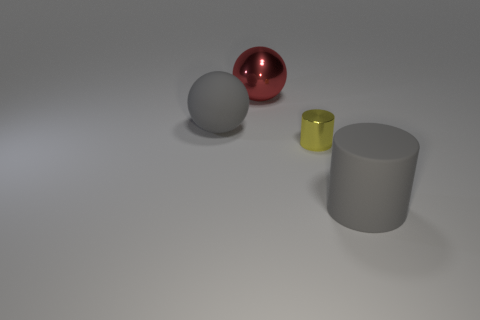There is a big gray matte thing that is in front of the small shiny cylinder; is its shape the same as the shiny object on the right side of the red metallic sphere?
Your answer should be very brief. Yes. How many rubber things are the same color as the matte cylinder?
Your response must be concise. 1. Is there a red rubber object of the same size as the matte cylinder?
Ensure brevity in your answer.  No. There is a rubber object left of the metal cylinder; does it have the same shape as the yellow object?
Ensure brevity in your answer.  No. Does the small yellow object have the same shape as the red thing?
Provide a succinct answer. No. Is there a big red object of the same shape as the small yellow object?
Offer a very short reply. No. There is a big gray matte thing to the left of the rubber thing that is in front of the tiny shiny thing; what shape is it?
Offer a very short reply. Sphere. What color is the thing that is to the left of the large red thing?
Provide a short and direct response. Gray. There is a thing that is the same material as the big gray cylinder; what is its size?
Offer a terse response. Large. Are there any green rubber cylinders?
Provide a short and direct response. No. 